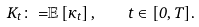<formula> <loc_0><loc_0><loc_500><loc_500>K _ { t } { \colon = } \mathbb { E } \left [ \kappa _ { t } \right ] , \quad t \in [ 0 , T ] .</formula> 